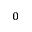Convert formula to latex. <formula><loc_0><loc_0><loc_500><loc_500>_ { 0 }</formula> 